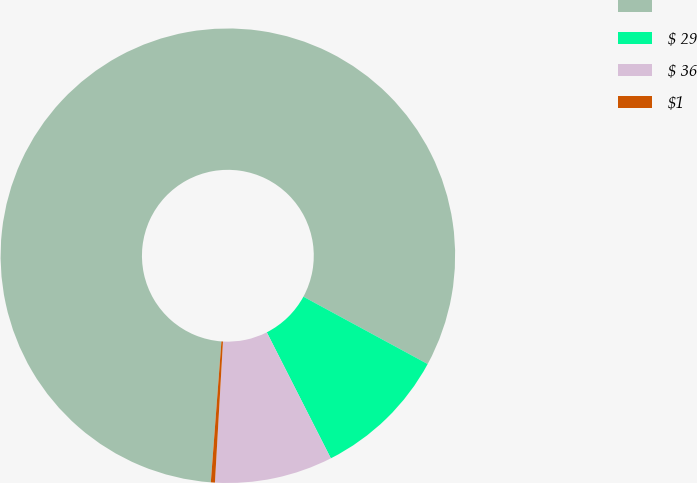Convert chart. <chart><loc_0><loc_0><loc_500><loc_500><pie_chart><ecel><fcel>$ 29<fcel>$ 36<fcel>$1<nl><fcel>81.71%<fcel>9.61%<fcel>8.39%<fcel>0.29%<nl></chart> 